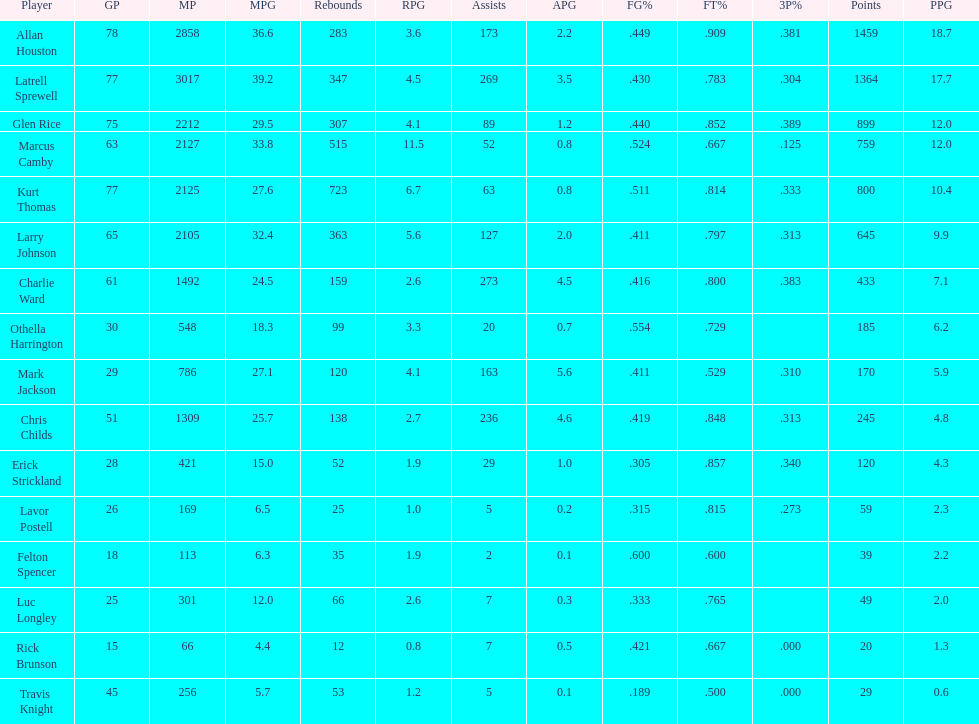Number of players on the team. 16. 